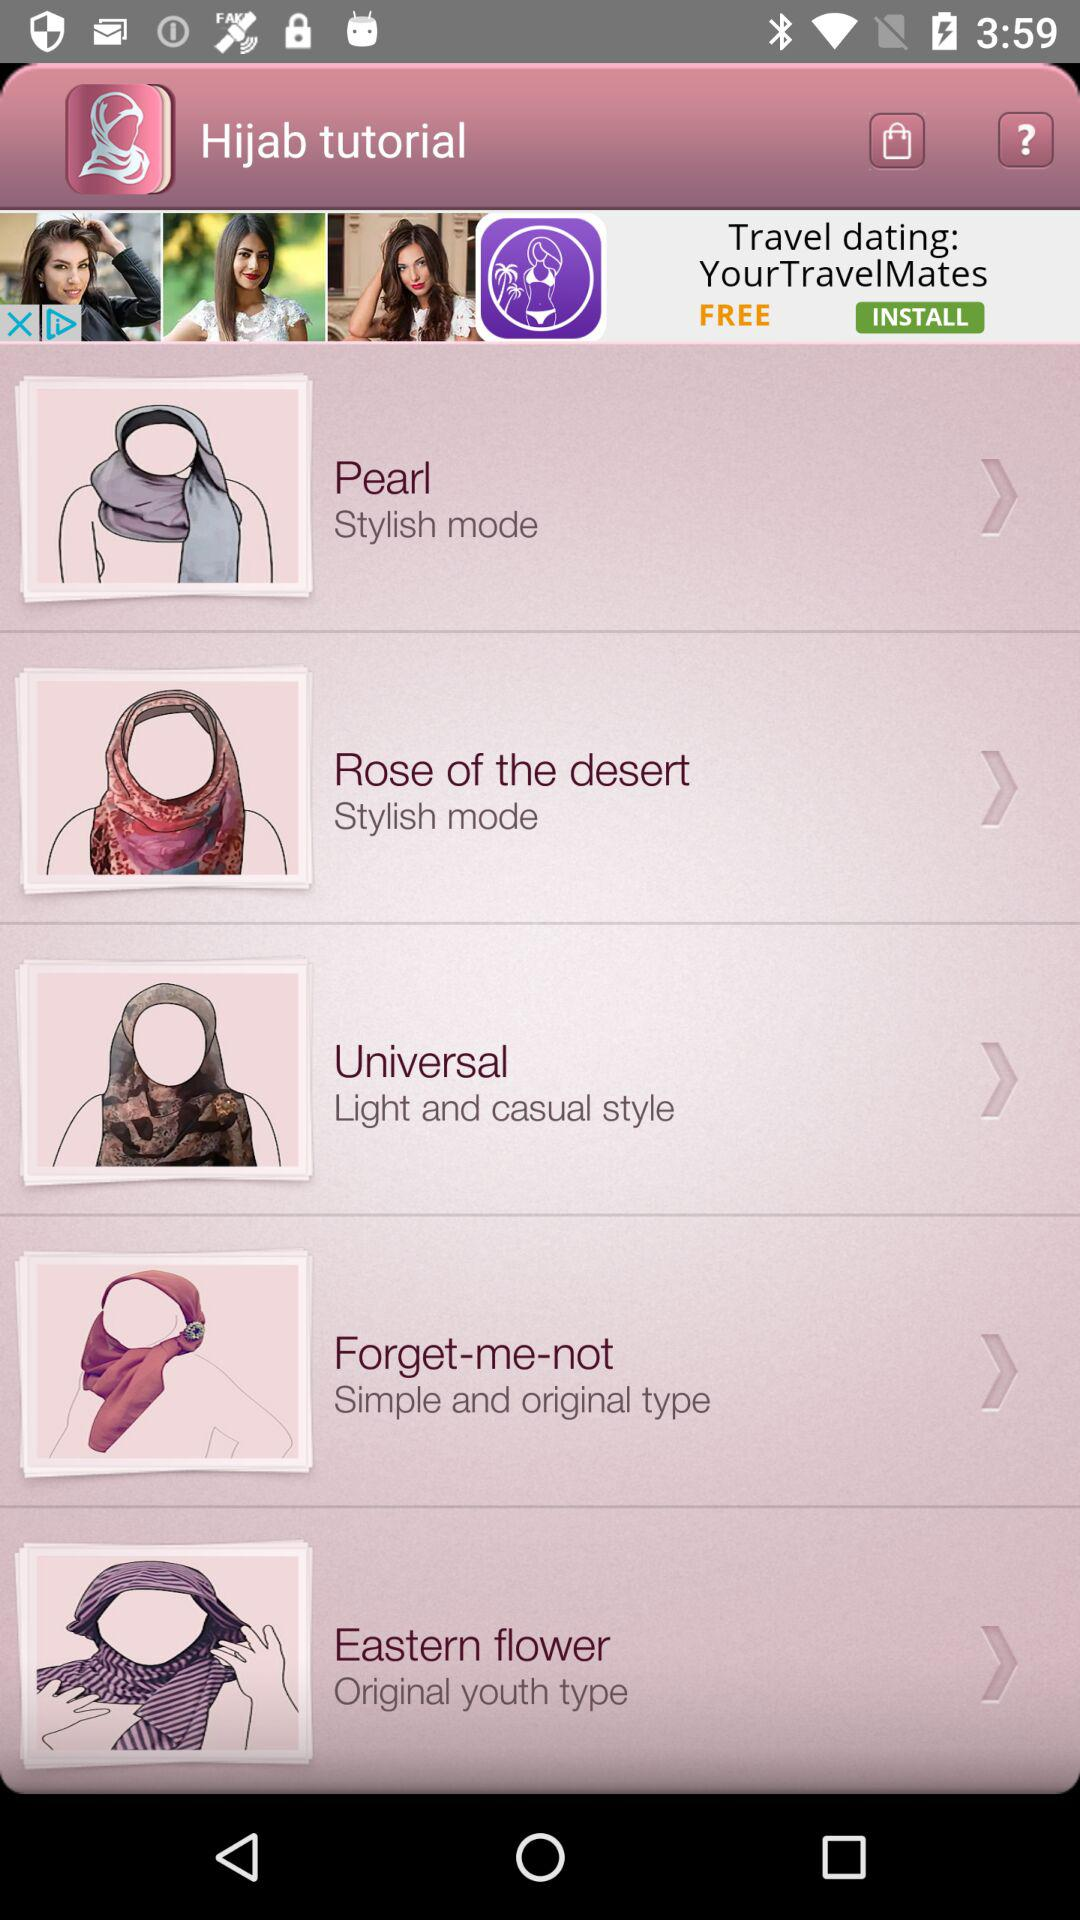What is the app's name? The app's name is "Hijab tutorial". 